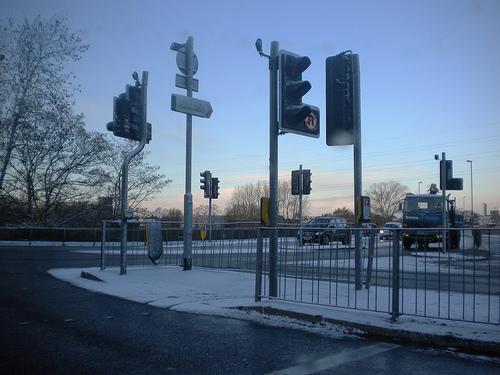How many trucks are on the road?
Give a very brief answer. 1. 